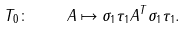Convert formula to latex. <formula><loc_0><loc_0><loc_500><loc_500>T _ { 0 } \colon \quad A \mapsto \sigma _ { 1 } \tau _ { 1 } A ^ { T } \sigma _ { 1 } \tau _ { 1 } .</formula> 